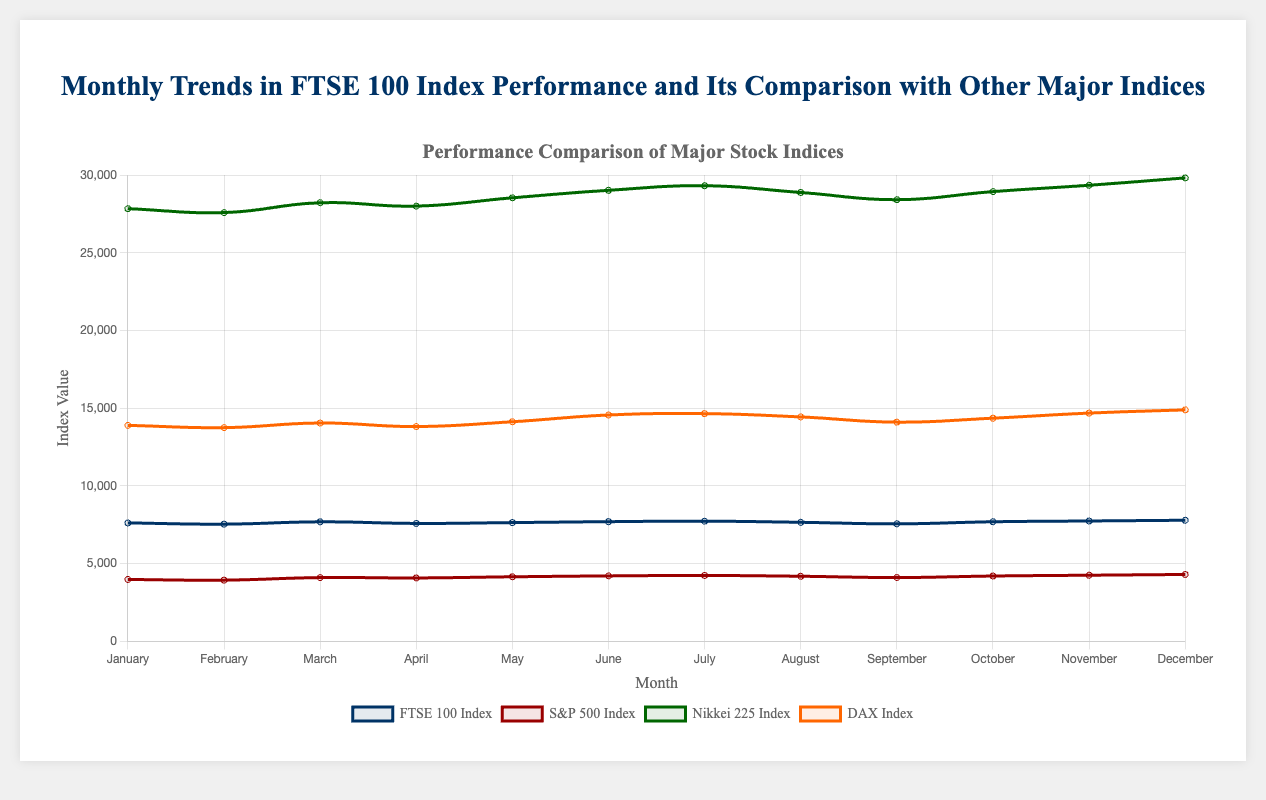Which index had the highest value at the end of December? By examining the data points at the end of December, we can see that the Nikkei 225 Index had the highest value at 29812.3.
Answer: Nikkei 225 During which month did the FTSE 100 Index see the largest increase compared to the previous month? The FTSE 100 Index had the largest increase from February to March, where it rose from 7541.9 to 7691.2, a difference of 149.3.
Answer: March How does the performance of the FTSE 100 Index in July compare to the S&P 500 Index in the same month? By comparing the values in July, the FTSE 100 Index is at 7734.1 while the S&P 500 Index is at 4240.8. The FTSE 100 is significantly higher in absolute value.
Answer: FTSE 100 is higher Which month saw a decline in the DAX Index but an increase in the Nikkei 225 Index? By reviewing the data, April shows that the DAX Index declined from 14047.5 to 13820.7, while the Nikkei 225 increased from 28215.4 to 27998.6.
Answer: April What is the average value of the FTSE 100 Index for the first quarter (January to March)? The FTSE 100 Index values for January to March are 7620.4, 7541.9, and 7691.2. The average is (7620.4 + 7541.9 + 7691.2) / 3 = 7617.83.
Answer: 7617.83 In which month did the S&P 500 Index have its lowest value, and what was it? Observing the dataset, the S&P 500 Index had its lowest value in February at 3941.2.
Answer: February, 3941.2 Which month saw the highest number of indices increasing their values? Reviewing the data, December saw increases in the FTSE 100 Index, S&P 500 Index, Nikkei 225 Index, and DAX Index. This indicates that December had the highest number of indices increasing their values.
Answer: December Calculate the difference in the closing values of the FTSE 100 Index between June and December. The FTSE 100 Index in June was 7701.3 and in December it was 7792.3. The difference is 7792.3 - 7701.3 = 91.
Answer: 91 What was the trend of the DAX Index in the second quarter (April to June)? Examining the values for the DAX Index in April (13820.7), May (14127.9), and June (14562.8), there was a consistent increasing trend.
Answer: Increasing Compare the change in the Nikkei 225 Index from May to June with the change from June to July. The Nikkei 225 Index increased from 28532.3 in May to 29014.2 in June (an increase of 481.9) and from 29014.2 to 29311.7 in July (an increase of 297.5).
Answer: Larger increase from May to June 